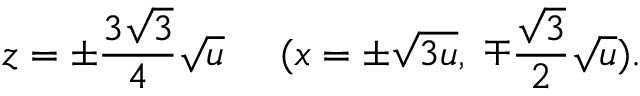<formula> <loc_0><loc_0><loc_500><loc_500>z = \pm \frac { 3 \sqrt { 3 } } { 4 } \sqrt { u } \, ( x = \pm \sqrt { 3 u } , \, \mp \frac { \sqrt { 3 } } { 2 } \sqrt { u } ) .</formula> 